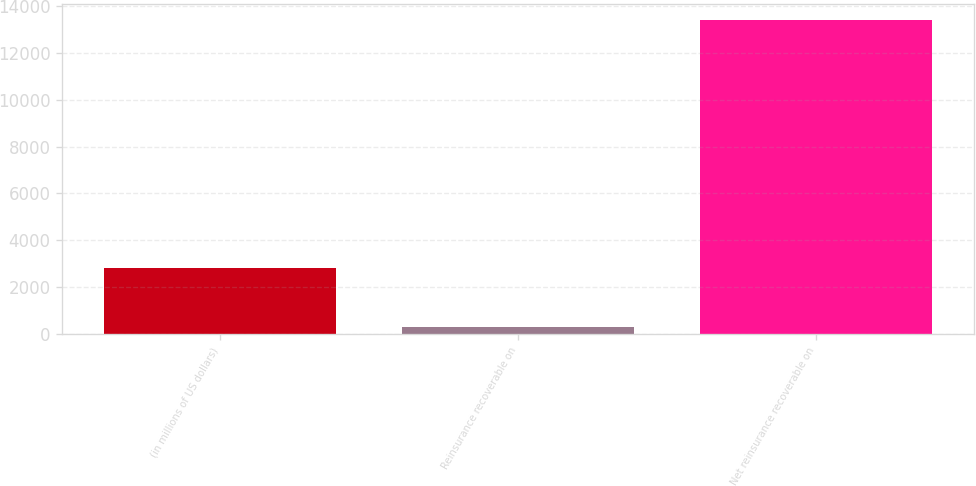Convert chart. <chart><loc_0><loc_0><loc_500><loc_500><bar_chart><fcel>(in millions of US dollars)<fcel>Reinsurance recoverable on<fcel>Net reinsurance recoverable on<nl><fcel>2799<fcel>281<fcel>13408<nl></chart> 